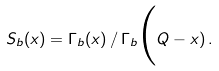Convert formula to latex. <formula><loc_0><loc_0><loc_500><loc_500>S _ { b } ( x ) = \Gamma _ { b } ( x ) \, / \, \Gamma _ { b } \Big ( Q - x ) \, .</formula> 